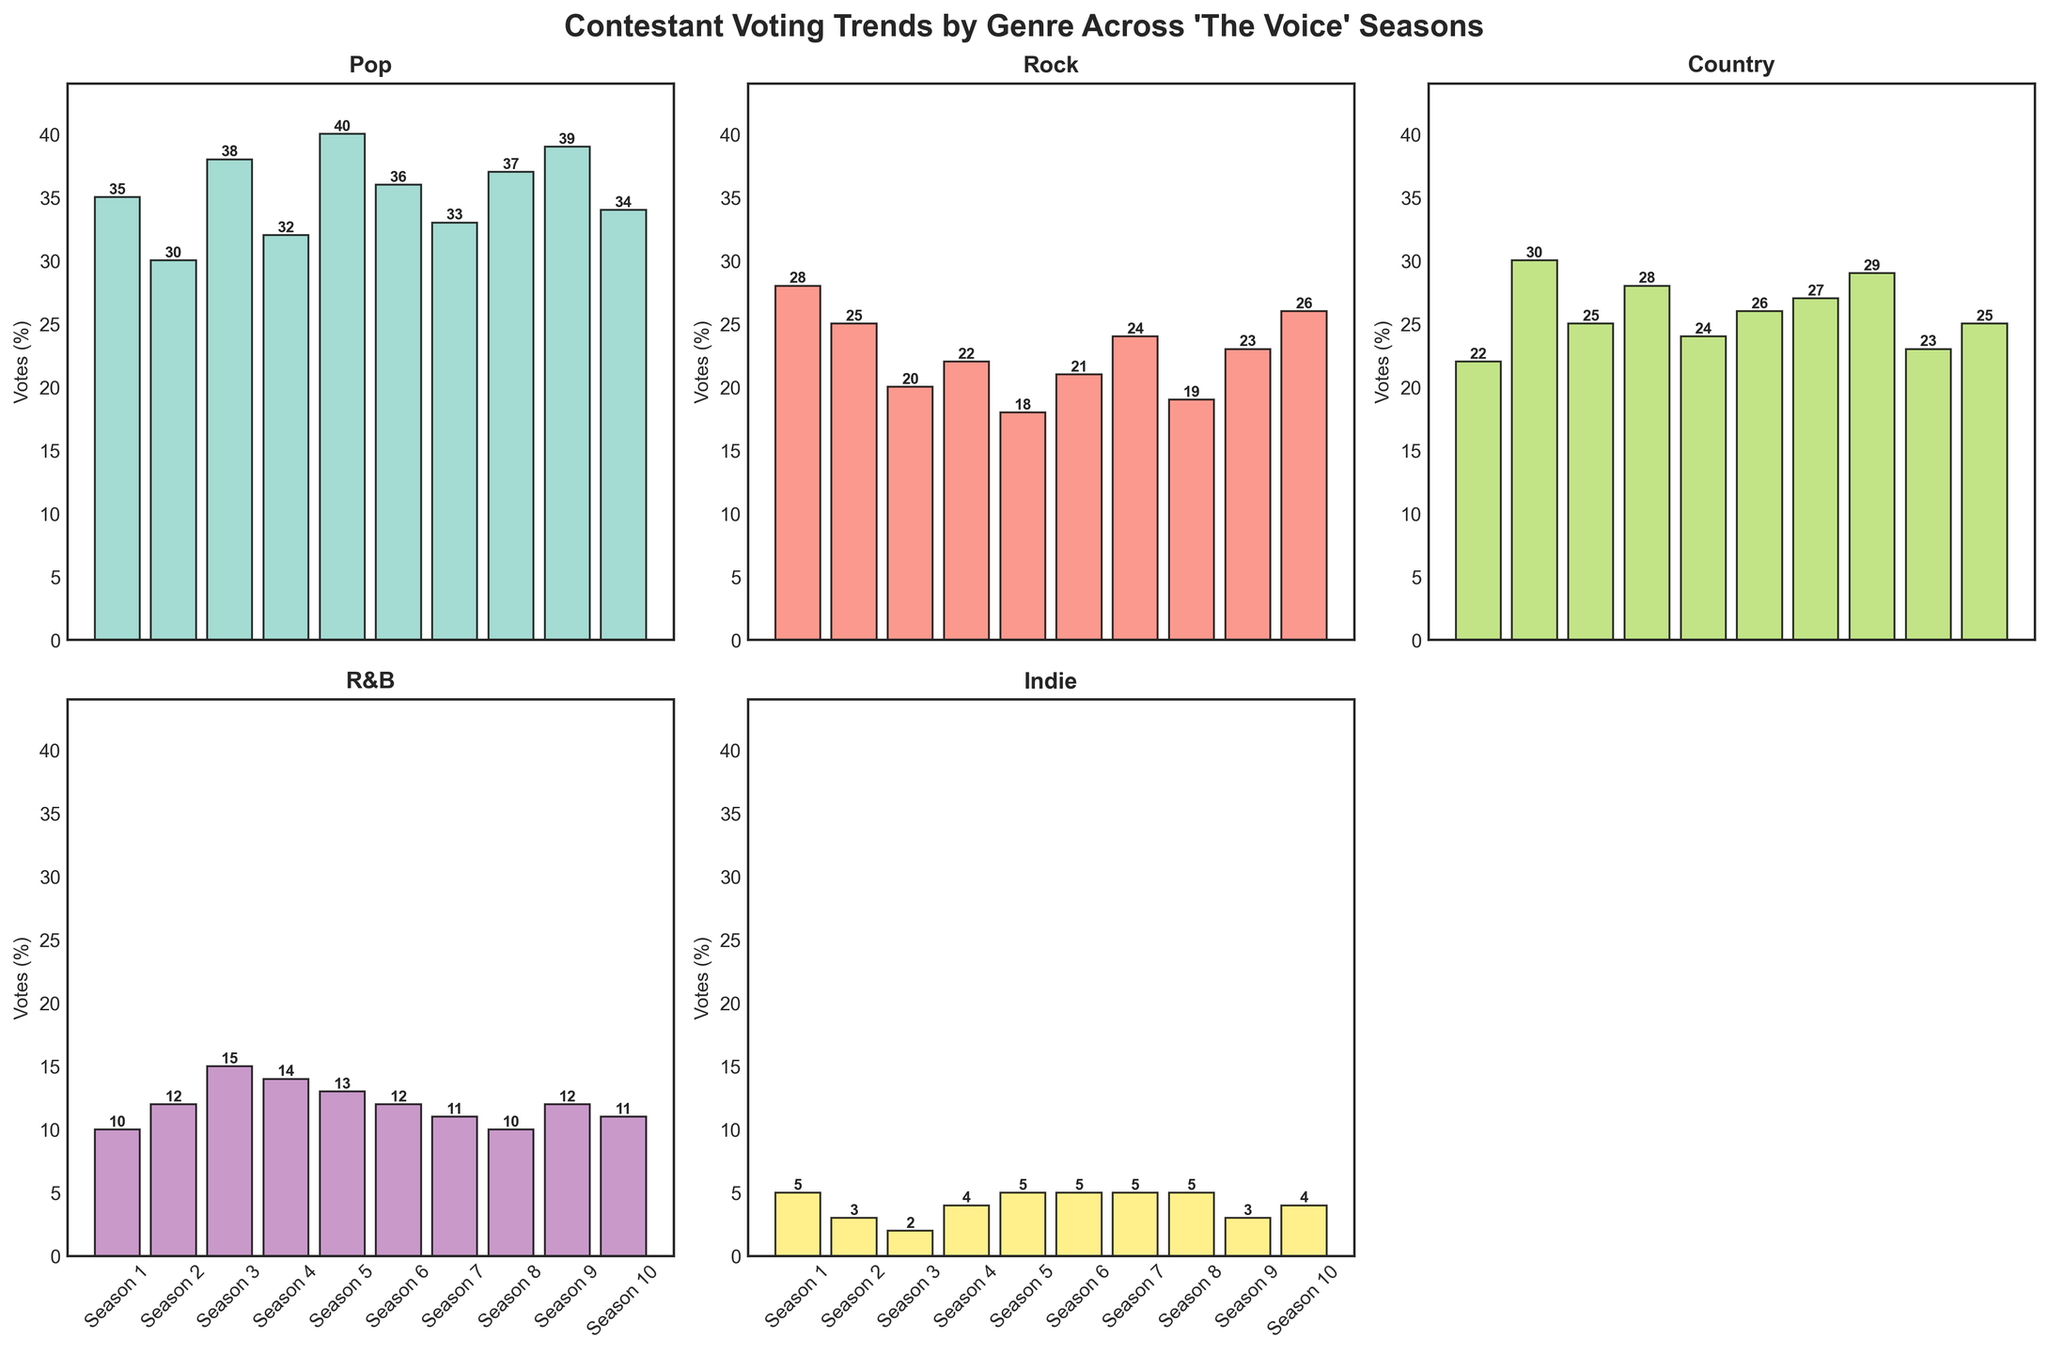How many total votes were received for Pop in Season 1? The bar for Pop in Season 1 indicates 35 votes.
Answer: 35 Which genre received the fewest votes in Season 5? The bars show that Indie received the fewest votes in Season 5 with 5 votes.
Answer: Indie Comparing Seasons 2 and 3, which season had a higher number of votes for Country and by how much? Season 2 had 30 votes for Country, while Season 3 had 25 votes. The difference is 30 - 25 = 5 votes.
Answer: Season 2 by 5 votes What is the average number of votes for Rock across all seasons? The votes for Rock across all seasons are [28, 25, 20, 22, 18, 21, 24, 19, 23, 26]. The sum is 226, and there are 10 seasons. The average is 226 / 10 = 22.6 votes.
Answer: 22.6 votes In which season did R&B receive the highest percentage of votes, and what was the percentage? The bar chart shows that Season 3 had the highest percentage of votes for R&B, with 15 votes.
Answer: Season 3 with 15 votes Which genre shows the most consistent voting pattern across all seasons? By visually inspecting the bars, Indie appears to have the most consistent voting pattern, with votes consistently around 3-5.
Answer: Indie How does the number of votes for Pop in Season 10 compare to the number of votes for Rock in the same season? The chart shows that Pop received 34 votes in Season 10, while Rock received 26 votes. Pop received 34 - 26 = 8 more votes than Rock.
Answer: Pop by 8 votes What is the total number of votes received by Country across all seasons? The votes for Country across all seasons are [22, 30, 25, 28, 24, 26, 27, 29, 23, 25]. The total is 259 votes.
Answer: 259 votes By how much did the number of votes for R&B in Season 8 decrease compared to Season 7? R&B had 11 votes in Season 7 and 10 votes in Season 8. The decrease is 11 - 10 = 1 vote.
Answer: Decreased by 1 vote Which season had the highest total votes across all genres, and what is that total? To find the highest total, sum up the votes for each season. Season 1: 35+28+22+10+5 = 100; Season 2: 30+25+30+12+3 = 100; Season 3: 38+20+25+15+2 = 100; Season 4: 32+22+28+14+4 = 100; Season 5: 40+18+24+13+5 = 100; Season 6: 36+21+26+12+5 = 100; Season 7: 33+24+27+11+5 = 100; Season 8: 37+19+29+10+5 = 100; Season 9: 39+23+23+12+3 = 100; Season 10: 34+26+25+11+4 = 100. All seasons have a total of 100 votes.
Answer: All seasons have 100 total votes 